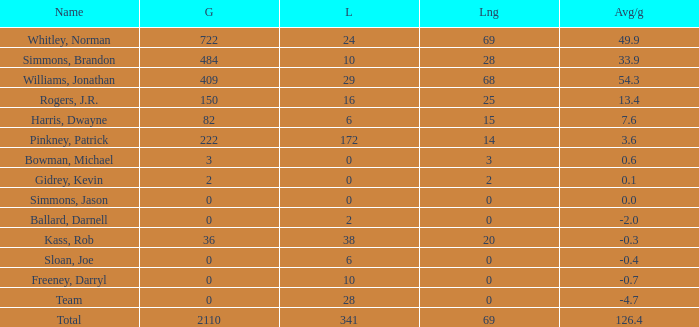What is the average Loss, when Avg/g is 0, and when Long is less than 0? None. 